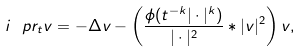Convert formula to latex. <formula><loc_0><loc_0><loc_500><loc_500>i \ p r _ { t } v = - \Delta v - \left ( \frac { \phi ( t ^ { - k } | \cdot | ^ { k } ) } { | \cdot | ^ { 2 } } \ast | v | ^ { 2 } \right ) v ,</formula> 